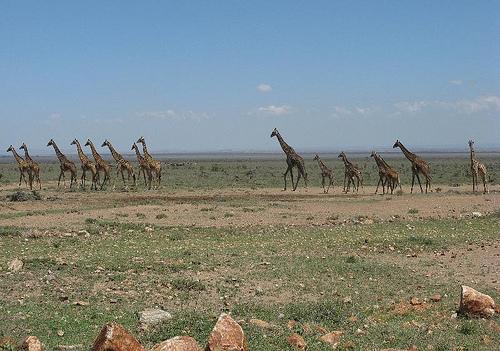What continent is this?
Write a very short answer. Africa. How many giraffes are in this pic?
Quick response, please. 15. What is the color of the grass?
Be succinct. Green. 